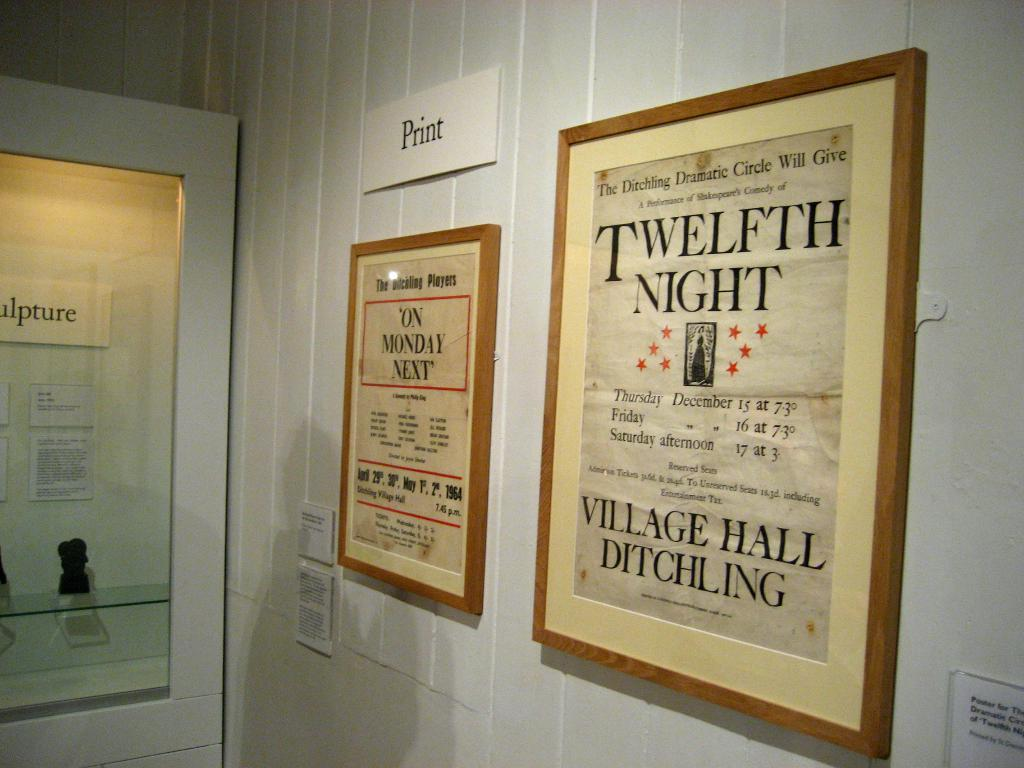<image>
Give a short and clear explanation of the subsequent image. a white board with word Print is on the very top of the wall 